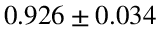<formula> <loc_0><loc_0><loc_500><loc_500>0 . 9 2 6 \pm 0 . 0 3 4</formula> 